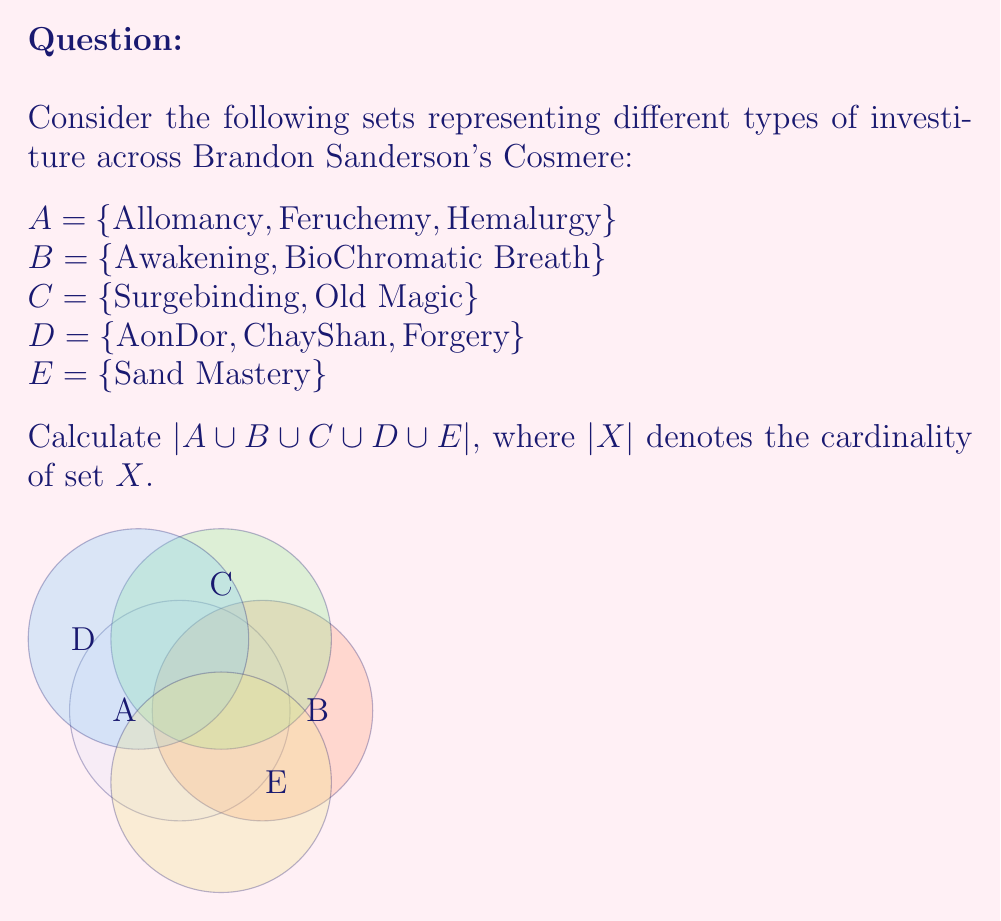Show me your answer to this math problem. To solve this problem, we need to follow these steps:

1) First, let's list out all the elements in each set:
   A = {Allomancy, Feruchemy, Hemalurgy}
   B = {Awakening, BioChromatic Breath}
   C = {Surgebinding, Old Magic}
   D = {AonDor, ChayShan, Forgery}
   E = {Sand Mastery}

2) Now, we need to find the union of all these sets. The union of sets includes all unique elements from all sets.

3) Let's combine all elements:
   A ∪ B ∪ C ∪ D ∪ E = {Allomancy, Feruchemy, Hemalurgy, Awakening, BioChromatic Breath, Surgebinding, Old Magic, AonDor, ChayShan, Forgery, Sand Mastery}

4) To find the cardinality of this union, we simply count the number of unique elements.

5) Counting the elements:
   $$|A \cup B \cup C \cup D \cup E| = 11$$

Therefore, there are 11 unique types of investiture in this union of sets.
Answer: 11 